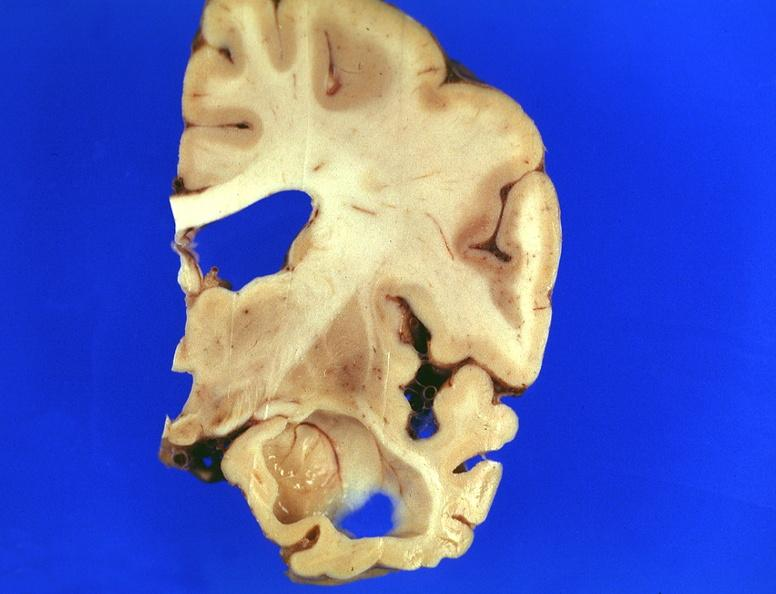s yellow color present?
Answer the question using a single word or phrase. No 